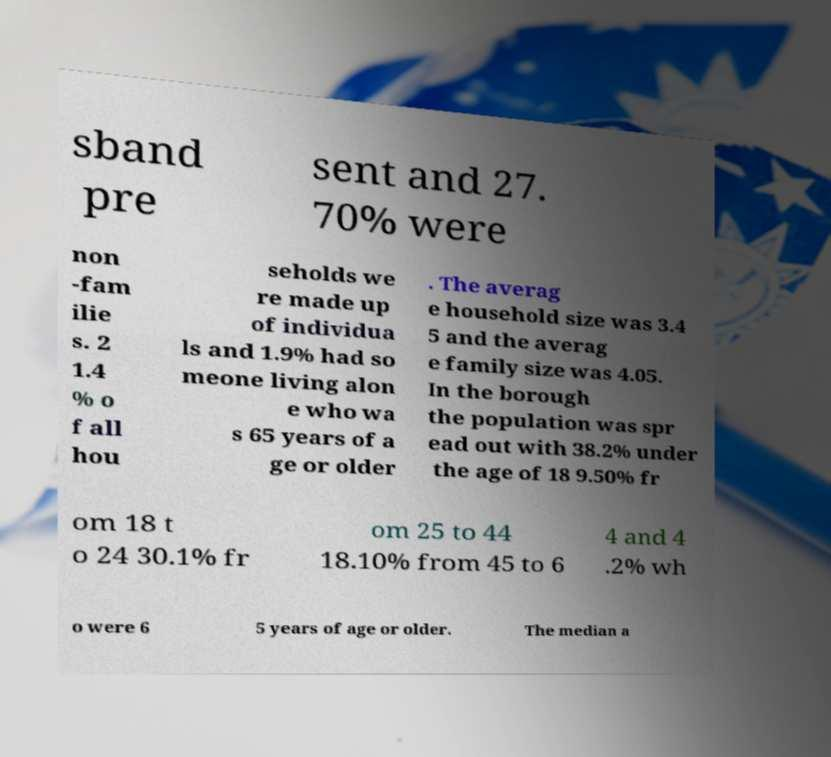Can you read and provide the text displayed in the image?This photo seems to have some interesting text. Can you extract and type it out for me? sband pre sent and 27. 70% were non -fam ilie s. 2 1.4 % o f all hou seholds we re made up of individua ls and 1.9% had so meone living alon e who wa s 65 years of a ge or older . The averag e household size was 3.4 5 and the averag e family size was 4.05. In the borough the population was spr ead out with 38.2% under the age of 18 9.50% fr om 18 t o 24 30.1% fr om 25 to 44 18.10% from 45 to 6 4 and 4 .2% wh o were 6 5 years of age or older. The median a 